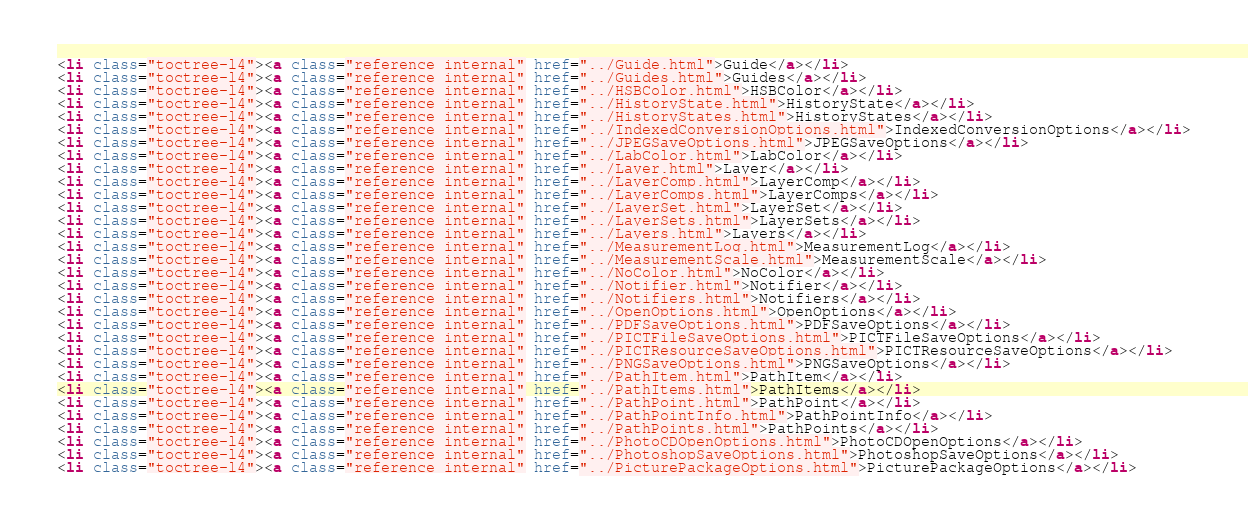Convert code to text. <code><loc_0><loc_0><loc_500><loc_500><_HTML_><li class="toctree-l4"><a class="reference internal" href="../Guide.html">Guide</a></li>
<li class="toctree-l4"><a class="reference internal" href="../Guides.html">Guides</a></li>
<li class="toctree-l4"><a class="reference internal" href="../HSBColor.html">HSBColor</a></li>
<li class="toctree-l4"><a class="reference internal" href="../HistoryState.html">HistoryState</a></li>
<li class="toctree-l4"><a class="reference internal" href="../HistoryStates.html">HistoryStates</a></li>
<li class="toctree-l4"><a class="reference internal" href="../IndexedConversionOptions.html">IndexedConversionOptions</a></li>
<li class="toctree-l4"><a class="reference internal" href="../JPEGSaveOptions.html">JPEGSaveOptions</a></li>
<li class="toctree-l4"><a class="reference internal" href="../LabColor.html">LabColor</a></li>
<li class="toctree-l4"><a class="reference internal" href="../Layer.html">Layer</a></li>
<li class="toctree-l4"><a class="reference internal" href="../LayerComp.html">LayerComp</a></li>
<li class="toctree-l4"><a class="reference internal" href="../LayerComps.html">LayerComps</a></li>
<li class="toctree-l4"><a class="reference internal" href="../LayerSet.html">LayerSet</a></li>
<li class="toctree-l4"><a class="reference internal" href="../LayerSets.html">LayerSets</a></li>
<li class="toctree-l4"><a class="reference internal" href="../Layers.html">Layers</a></li>
<li class="toctree-l4"><a class="reference internal" href="../MeasurementLog.html">MeasurementLog</a></li>
<li class="toctree-l4"><a class="reference internal" href="../MeasurementScale.html">MeasurementScale</a></li>
<li class="toctree-l4"><a class="reference internal" href="../NoColor.html">NoColor</a></li>
<li class="toctree-l4"><a class="reference internal" href="../Notifier.html">Notifier</a></li>
<li class="toctree-l4"><a class="reference internal" href="../Notifiers.html">Notifiers</a></li>
<li class="toctree-l4"><a class="reference internal" href="../OpenOptions.html">OpenOptions</a></li>
<li class="toctree-l4"><a class="reference internal" href="../PDFSaveOptions.html">PDFSaveOptions</a></li>
<li class="toctree-l4"><a class="reference internal" href="../PICTFileSaveOptions.html">PICTFileSaveOptions</a></li>
<li class="toctree-l4"><a class="reference internal" href="../PICTResourceSaveOptions.html">PICTResourceSaveOptions</a></li>
<li class="toctree-l4"><a class="reference internal" href="../PNGSaveOptions.html">PNGSaveOptions</a></li>
<li class="toctree-l4"><a class="reference internal" href="../PathItem.html">PathItem</a></li>
<li class="toctree-l4"><a class="reference internal" href="../PathItems.html">PathItems</a></li>
<li class="toctree-l4"><a class="reference internal" href="../PathPoint.html">PathPoint</a></li>
<li class="toctree-l4"><a class="reference internal" href="../PathPointInfo.html">PathPointInfo</a></li>
<li class="toctree-l4"><a class="reference internal" href="../PathPoints.html">PathPoints</a></li>
<li class="toctree-l4"><a class="reference internal" href="../PhotoCDOpenOptions.html">PhotoCDOpenOptions</a></li>
<li class="toctree-l4"><a class="reference internal" href="../PhotoshopSaveOptions.html">PhotoshopSaveOptions</a></li>
<li class="toctree-l4"><a class="reference internal" href="../PicturePackageOptions.html">PicturePackageOptions</a></li></code> 